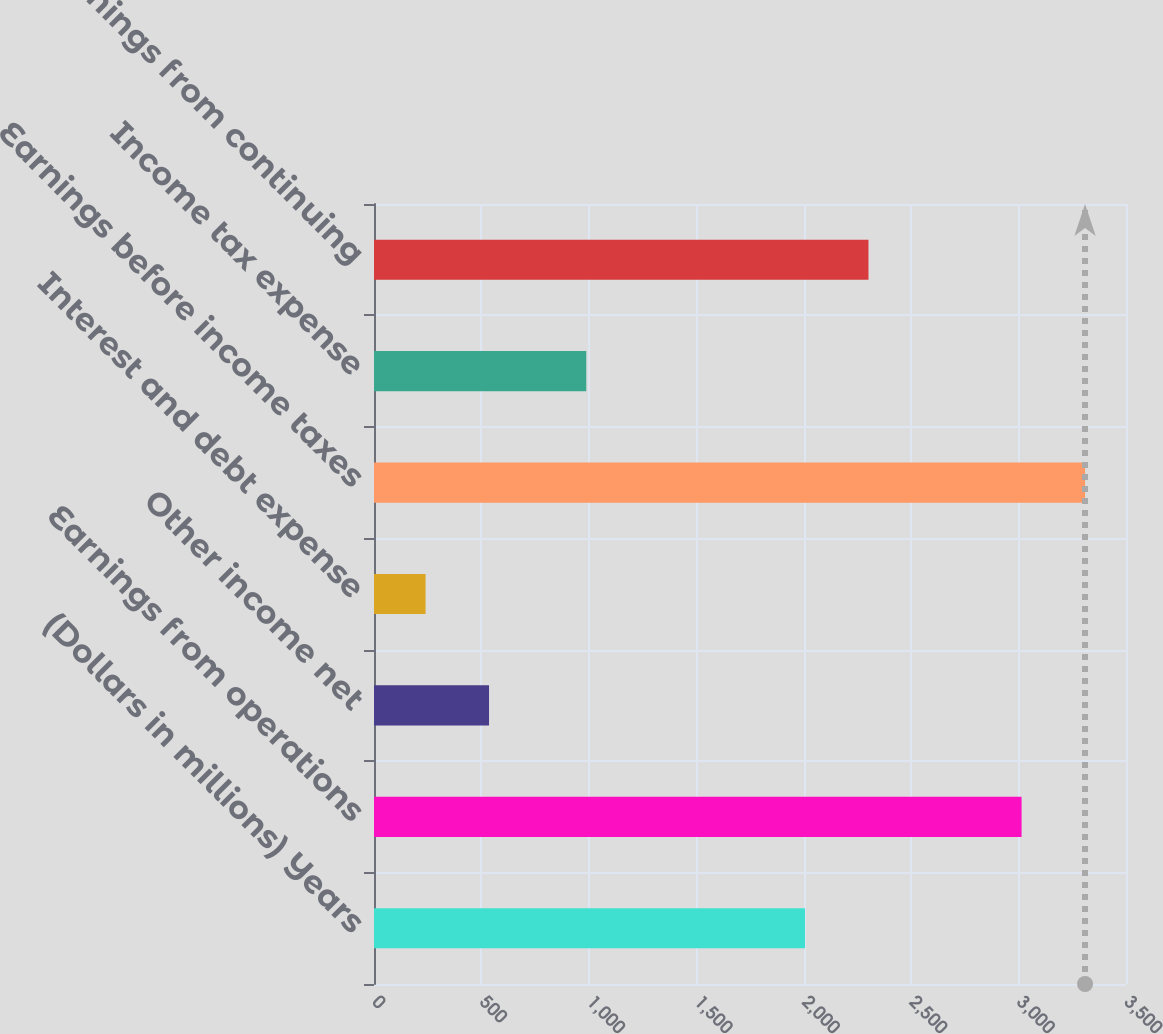Convert chart. <chart><loc_0><loc_0><loc_500><loc_500><bar_chart><fcel>(Dollars in millions) Years<fcel>Earnings from operations<fcel>Other income net<fcel>Interest and debt expense<fcel>Earnings before income taxes<fcel>Income tax expense<fcel>Net earnings from continuing<nl><fcel>2006<fcel>3014<fcel>535.4<fcel>240<fcel>3309.4<fcel>988<fcel>2301.4<nl></chart> 